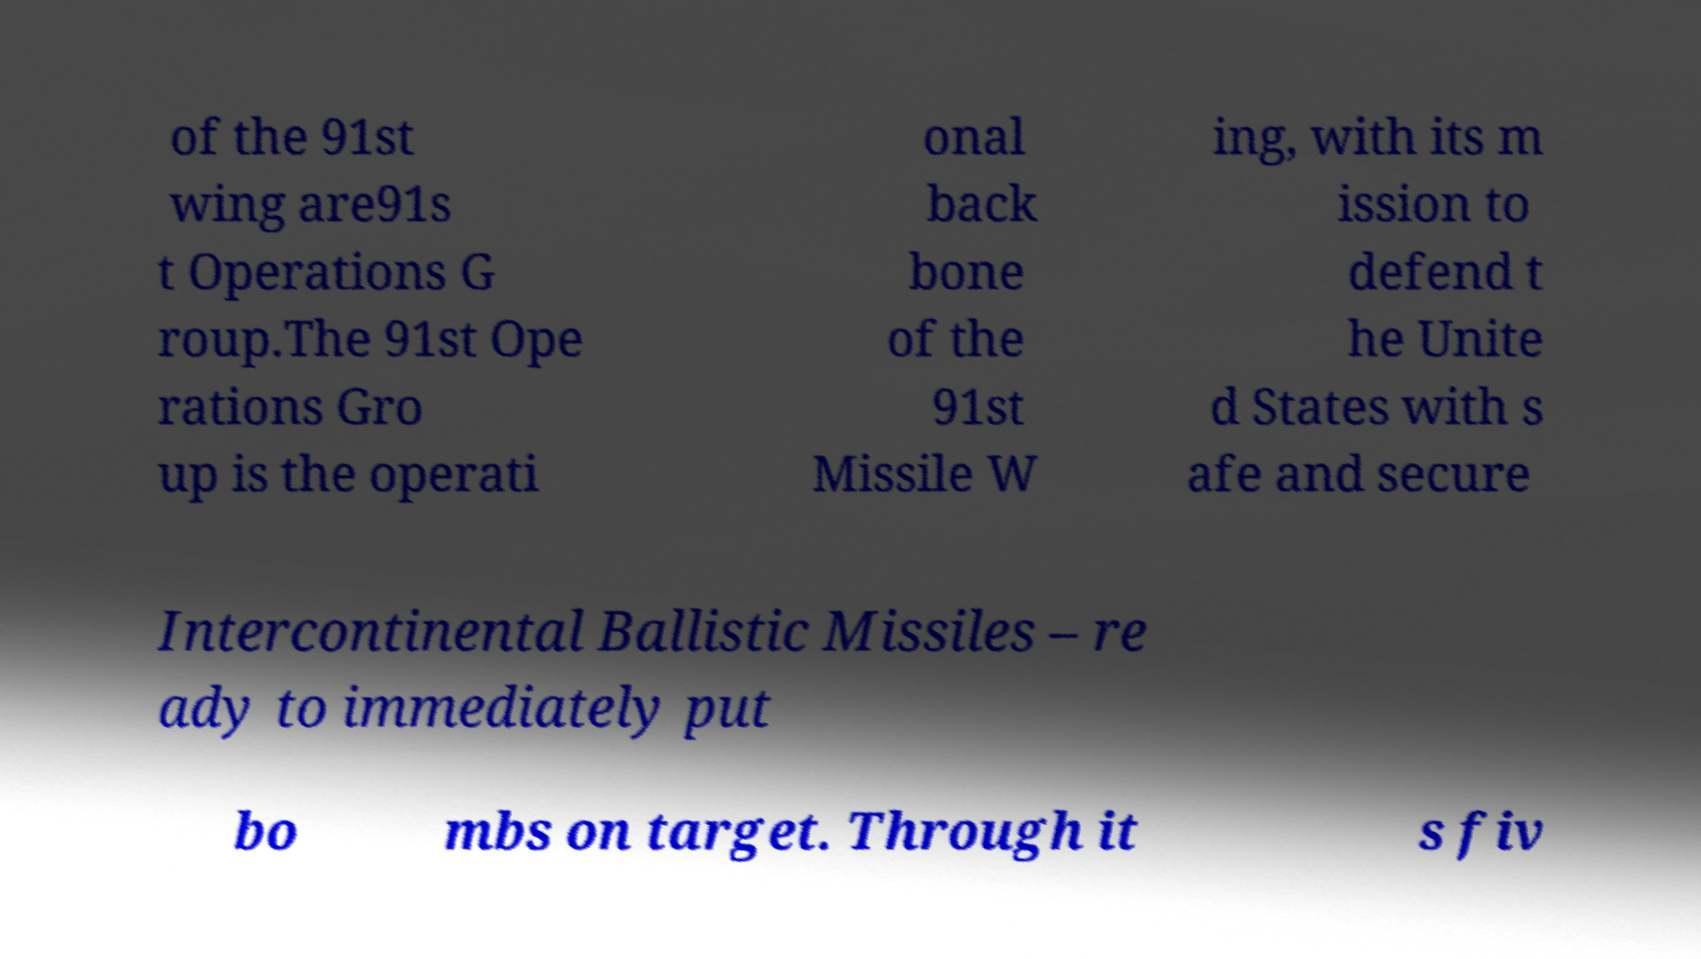Could you assist in decoding the text presented in this image and type it out clearly? of the 91st wing are91s t Operations G roup.The 91st Ope rations Gro up is the operati onal back bone of the 91st Missile W ing, with its m ission to defend t he Unite d States with s afe and secure Intercontinental Ballistic Missiles – re ady to immediately put bo mbs on target. Through it s fiv 